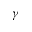<formula> <loc_0><loc_0><loc_500><loc_500>\gamma</formula> 